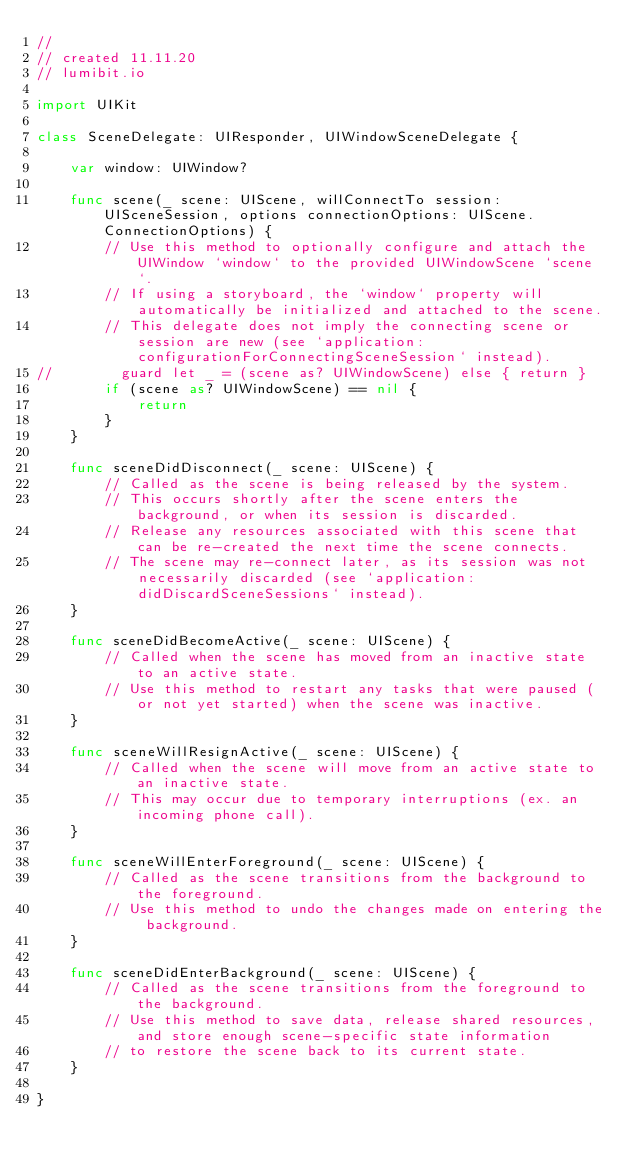Convert code to text. <code><loc_0><loc_0><loc_500><loc_500><_Swift_>//
// created 11.11.20
// lumibit.io

import UIKit

class SceneDelegate: UIResponder, UIWindowSceneDelegate {

    var window: UIWindow?

    func scene(_ scene: UIScene, willConnectTo session: UISceneSession, options connectionOptions: UIScene.ConnectionOptions) {
        // Use this method to optionally configure and attach the UIWindow `window` to the provided UIWindowScene `scene`.
        // If using a storyboard, the `window` property will automatically be initialized and attached to the scene.
        // This delegate does not imply the connecting scene or session are new (see `application:configurationForConnectingSceneSession` instead).
//        guard let _ = (scene as? UIWindowScene) else { return }
        if (scene as? UIWindowScene) == nil {
            return
        }
    }

    func sceneDidDisconnect(_ scene: UIScene) {
        // Called as the scene is being released by the system.
        // This occurs shortly after the scene enters the background, or when its session is discarded.
        // Release any resources associated with this scene that can be re-created the next time the scene connects.
        // The scene may re-connect later, as its session was not necessarily discarded (see `application:didDiscardSceneSessions` instead).
    }

    func sceneDidBecomeActive(_ scene: UIScene) {
        // Called when the scene has moved from an inactive state to an active state.
        // Use this method to restart any tasks that were paused (or not yet started) when the scene was inactive.
    }

    func sceneWillResignActive(_ scene: UIScene) {
        // Called when the scene will move from an active state to an inactive state.
        // This may occur due to temporary interruptions (ex. an incoming phone call).
    }

    func sceneWillEnterForeground(_ scene: UIScene) {
        // Called as the scene transitions from the background to the foreground.
        // Use this method to undo the changes made on entering the background.
    }

    func sceneDidEnterBackground(_ scene: UIScene) {
        // Called as the scene transitions from the foreground to the background.
        // Use this method to save data, release shared resources, and store enough scene-specific state information
        // to restore the scene back to its current state.
    }

}
</code> 